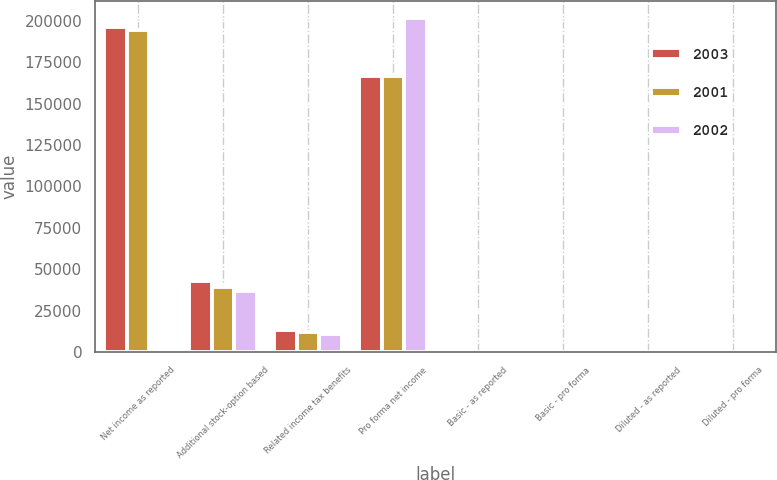<chart> <loc_0><loc_0><loc_500><loc_500><stacked_bar_chart><ecel><fcel>Net income as reported<fcel>Additional stock-option based<fcel>Related income tax benefits<fcel>Pro forma net income<fcel>Basic - as reported<fcel>Basic - pro forma<fcel>Diluted - as reported<fcel>Diluted - pro forma<nl><fcel>2003<fcel>195868<fcel>42688<fcel>13471<fcel>166651<fcel>1.59<fcel>1.35<fcel>1.52<fcel>1.3<nl><fcel>2001<fcel>194254<fcel>39369<fcel>11985<fcel>166870<fcel>1.58<fcel>1.36<fcel>1.52<fcel>1.31<nl><fcel>2002<fcel>1.84<fcel>37028<fcel>11248<fcel>201707<fcel>1.84<fcel>1.63<fcel>1.77<fcel>1.59<nl></chart> 